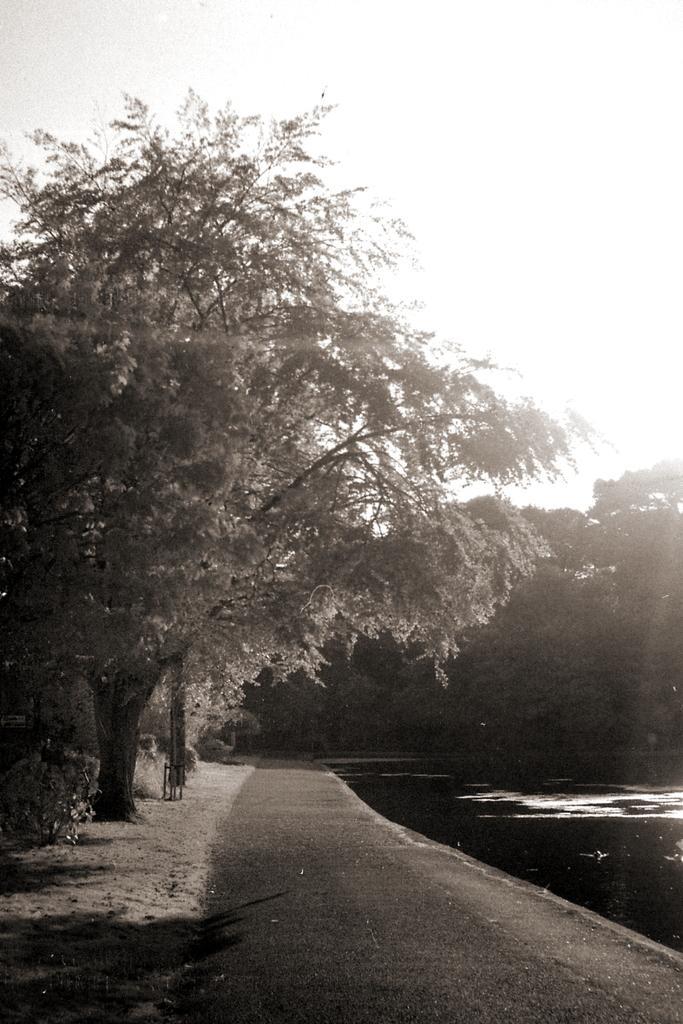Please provide a concise description of this image. In this image there is a lake, beside the lake there is a road, on the left there are trees, in the background there are trees. 